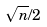<formula> <loc_0><loc_0><loc_500><loc_500>\sqrt { n } / 2</formula> 